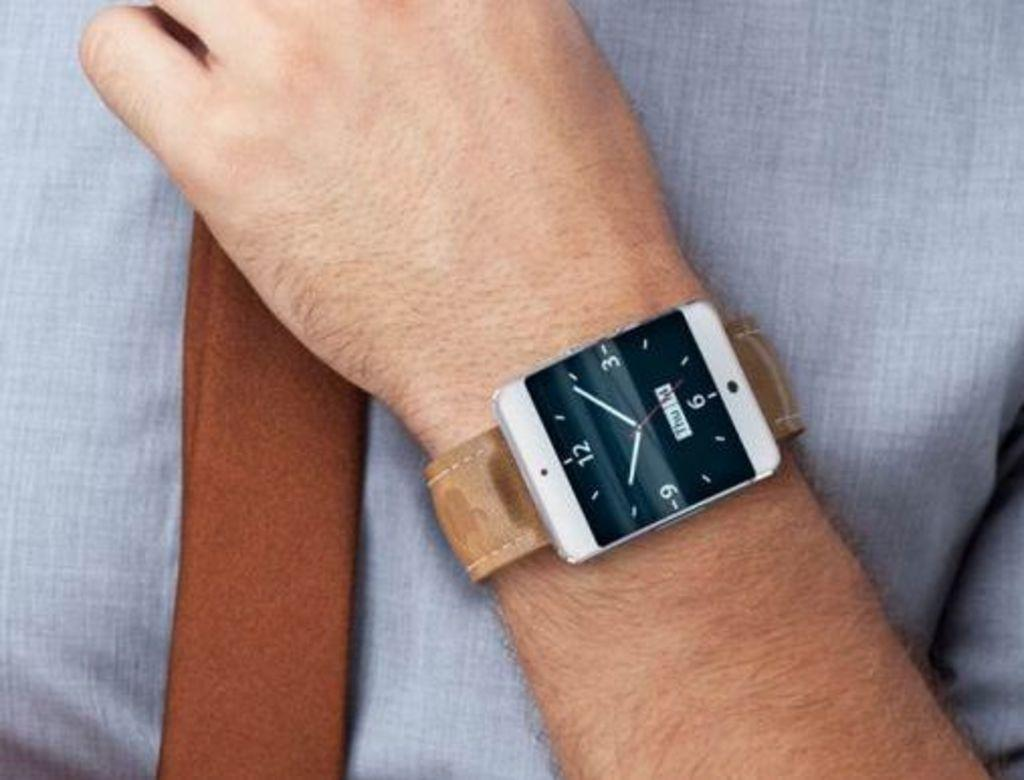Provide a one-sentence caption for the provided image. A square watch that has the date of Thrus the 14th. 